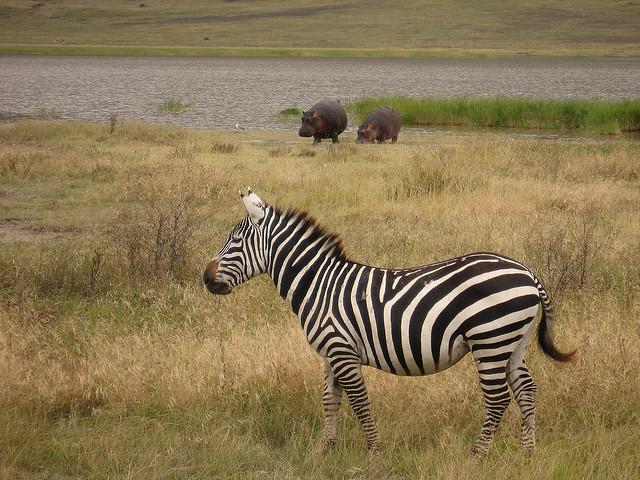What could the zebra be looking at?
Write a very short answer. Another zebra. Is the grass green?
Write a very short answer. No. Is the zebra alone?
Give a very brief answer. No. Is this an adult zebra?
Short answer required. Yes. Are the hippos hungry?
Short answer required. No. What is the weather like?
Quick response, please. Sunny. 